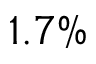<formula> <loc_0><loc_0><loc_500><loc_500>1 . 7 \%</formula> 